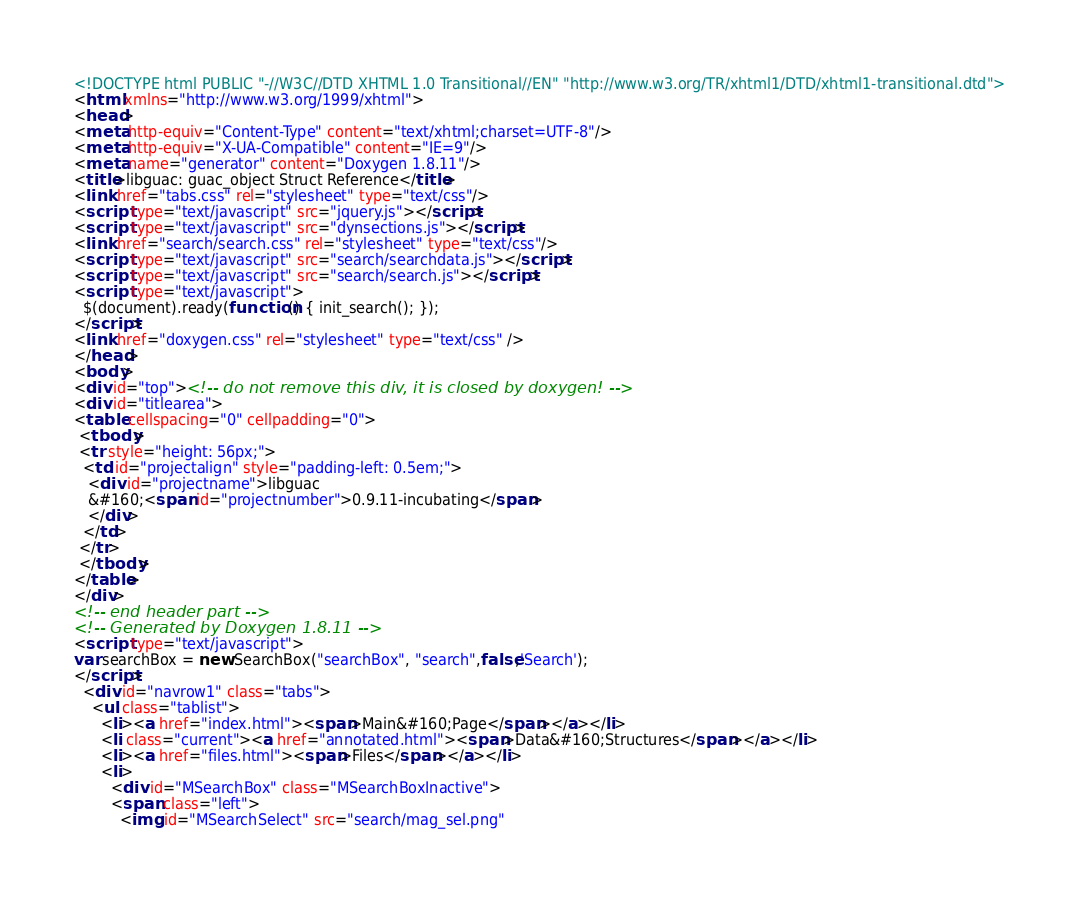Convert code to text. <code><loc_0><loc_0><loc_500><loc_500><_HTML_><!DOCTYPE html PUBLIC "-//W3C//DTD XHTML 1.0 Transitional//EN" "http://www.w3.org/TR/xhtml1/DTD/xhtml1-transitional.dtd">
<html xmlns="http://www.w3.org/1999/xhtml">
<head>
<meta http-equiv="Content-Type" content="text/xhtml;charset=UTF-8"/>
<meta http-equiv="X-UA-Compatible" content="IE=9"/>
<meta name="generator" content="Doxygen 1.8.11"/>
<title>libguac: guac_object Struct Reference</title>
<link href="tabs.css" rel="stylesheet" type="text/css"/>
<script type="text/javascript" src="jquery.js"></script>
<script type="text/javascript" src="dynsections.js"></script>
<link href="search/search.css" rel="stylesheet" type="text/css"/>
<script type="text/javascript" src="search/searchdata.js"></script>
<script type="text/javascript" src="search/search.js"></script>
<script type="text/javascript">
  $(document).ready(function() { init_search(); });
</script>
<link href="doxygen.css" rel="stylesheet" type="text/css" />
</head>
<body>
<div id="top"><!-- do not remove this div, it is closed by doxygen! -->
<div id="titlearea">
<table cellspacing="0" cellpadding="0">
 <tbody>
 <tr style="height: 56px;">
  <td id="projectalign" style="padding-left: 0.5em;">
   <div id="projectname">libguac
   &#160;<span id="projectnumber">0.9.11-incubating</span>
   </div>
  </td>
 </tr>
 </tbody>
</table>
</div>
<!-- end header part -->
<!-- Generated by Doxygen 1.8.11 -->
<script type="text/javascript">
var searchBox = new SearchBox("searchBox", "search",false,'Search');
</script>
  <div id="navrow1" class="tabs">
    <ul class="tablist">
      <li><a href="index.html"><span>Main&#160;Page</span></a></li>
      <li class="current"><a href="annotated.html"><span>Data&#160;Structures</span></a></li>
      <li><a href="files.html"><span>Files</span></a></li>
      <li>
        <div id="MSearchBox" class="MSearchBoxInactive">
        <span class="left">
          <img id="MSearchSelect" src="search/mag_sel.png"</code> 